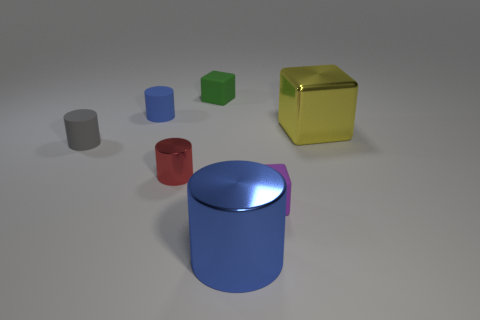How big is the matte cylinder in front of the big thing that is right of the tiny block to the right of the large cylinder?
Give a very brief answer. Small. There is a matte block that is behind the yellow shiny cube; does it have the same size as the tiny purple rubber object?
Your answer should be compact. Yes. How many other objects are there of the same material as the red cylinder?
Make the answer very short. 2. Is the number of small red things greater than the number of tiny blue matte blocks?
Your answer should be compact. Yes. What is the material of the blue cylinder that is to the left of the blue thing that is in front of the matte block on the right side of the green cube?
Ensure brevity in your answer.  Rubber. Do the large cube and the small metallic cylinder have the same color?
Provide a short and direct response. No. Are there any small rubber cylinders of the same color as the big shiny cylinder?
Your response must be concise. Yes. There is a blue thing that is the same size as the green matte object; what shape is it?
Keep it short and to the point. Cylinder. Are there fewer big brown cylinders than tiny cubes?
Your answer should be very brief. Yes. What number of matte cylinders have the same size as the yellow thing?
Your answer should be compact. 0. 